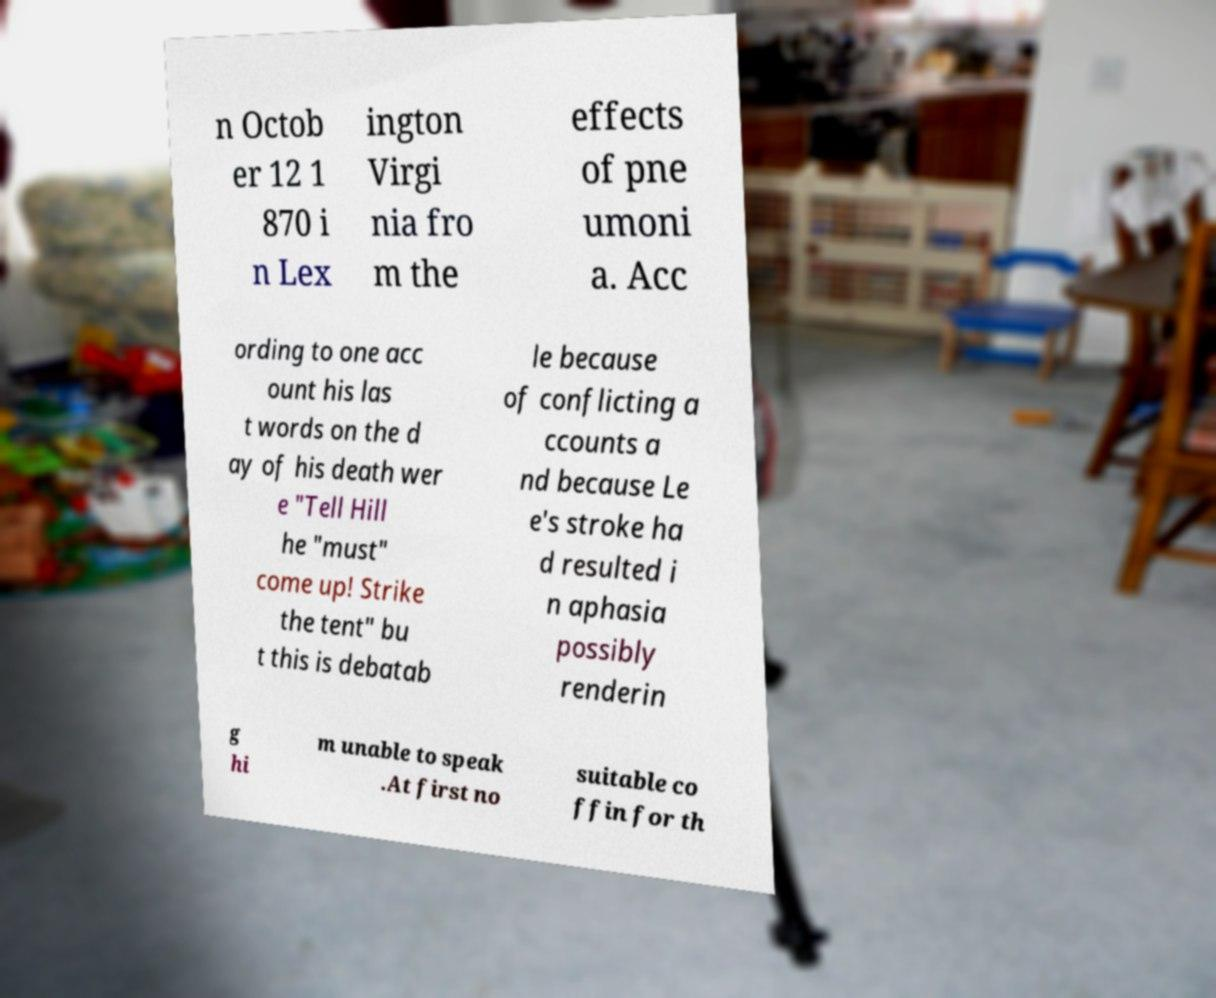Could you assist in decoding the text presented in this image and type it out clearly? n Octob er 12 1 870 i n Lex ington Virgi nia fro m the effects of pne umoni a. Acc ording to one acc ount his las t words on the d ay of his death wer e "Tell Hill he "must" come up! Strike the tent" bu t this is debatab le because of conflicting a ccounts a nd because Le e's stroke ha d resulted i n aphasia possibly renderin g hi m unable to speak .At first no suitable co ffin for th 